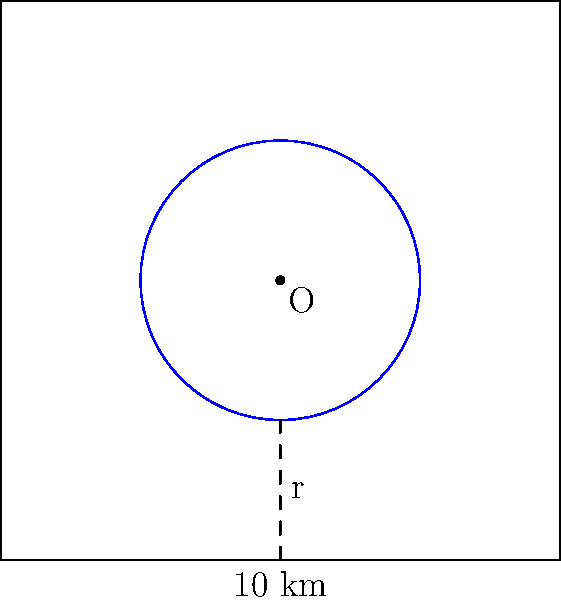In a square city grid with sides measuring 10 km, a circular park is planned at the center. If the park's radius is 2.5 km, what percentage of the city's total area will be occupied by the park? Round your answer to the nearest whole percent. To solve this problem, we need to follow these steps:

1. Calculate the area of the square city:
   $A_{square} = s^2 = 10^2 = 100$ km²

2. Calculate the area of the circular park:
   $A_{circle} = \pi r^2 = \pi (2.5)^2 = 6.25\pi$ km²

3. Calculate the percentage of the city occupied by the park:
   $Percentage = \frac{A_{circle}}{A_{square}} \times 100\%$
   
   $= \frac{6.25\pi}{100} \times 100\%$
   
   $= 0.0625\pi \times 100\%$
   
   $\approx 19.63\%$

4. Rounding to the nearest whole percent:
   19.63% rounds to 20%

Therefore, the circular park will occupy approximately 20% of the city's total area.
Answer: 20% 